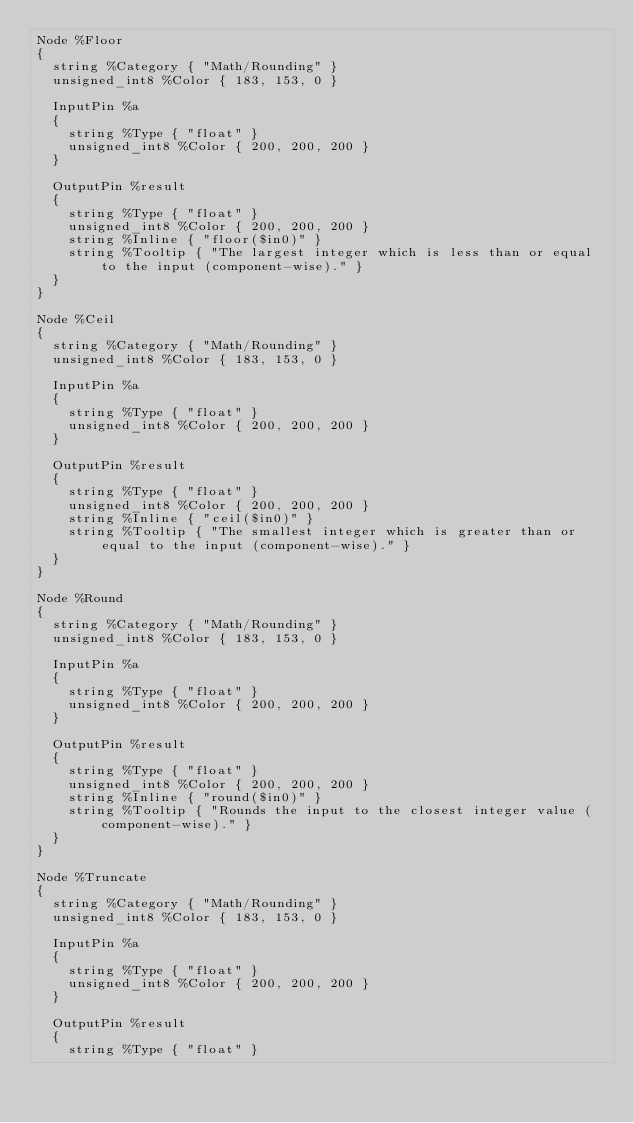Convert code to text. <code><loc_0><loc_0><loc_500><loc_500><_SQL_>Node %Floor
{
  string %Category { "Math/Rounding" }
  unsigned_int8 %Color { 183, 153, 0 }

  InputPin %a
  {
    string %Type { "float" }
    unsigned_int8 %Color { 200, 200, 200 }
  }

  OutputPin %result
  {
    string %Type { "float" }
    unsigned_int8 %Color { 200, 200, 200 }
    string %Inline { "floor($in0)" }
    string %Tooltip { "The largest integer which is less than or equal to the input (component-wise)." }
  }
}

Node %Ceil
{
  string %Category { "Math/Rounding" }
  unsigned_int8 %Color { 183, 153, 0 }

  InputPin %a
  {
    string %Type { "float" }
    unsigned_int8 %Color { 200, 200, 200 }
  }

  OutputPin %result
  {
    string %Type { "float" }
    unsigned_int8 %Color { 200, 200, 200 }
    string %Inline { "ceil($in0)" }
    string %Tooltip { "The smallest integer which is greater than or equal to the input (component-wise)." }
  }
}

Node %Round
{
  string %Category { "Math/Rounding" }
  unsigned_int8 %Color { 183, 153, 0 }

  InputPin %a
  {
    string %Type { "float" }
    unsigned_int8 %Color { 200, 200, 200 }
  }

  OutputPin %result
  {
    string %Type { "float" }
    unsigned_int8 %Color { 200, 200, 200 }
    string %Inline { "round($in0)" }
    string %Tooltip { "Rounds the input to the closest integer value (component-wise)." }
  }
}

Node %Truncate
{
  string %Category { "Math/Rounding" }
  unsigned_int8 %Color { 183, 153, 0 }

  InputPin %a
  {
    string %Type { "float" }
    unsigned_int8 %Color { 200, 200, 200 }
  }

  OutputPin %result
  {
    string %Type { "float" }</code> 